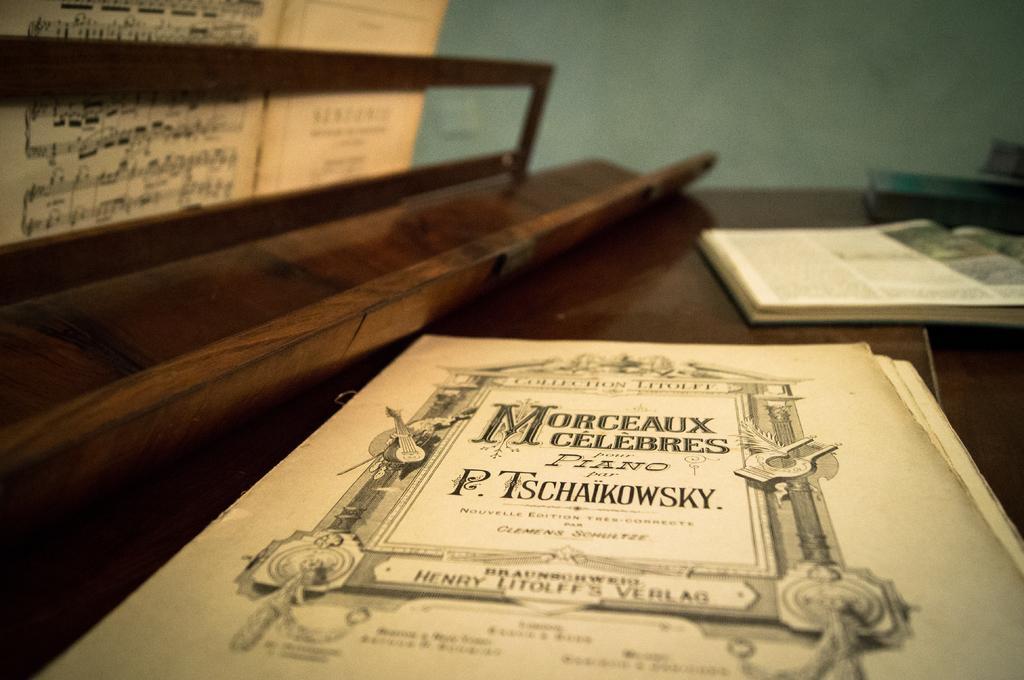Describe this image in one or two sentences. This image is taken indoors. At the bottom of the image there is a table with a few things on it. In the background there is a wall. 